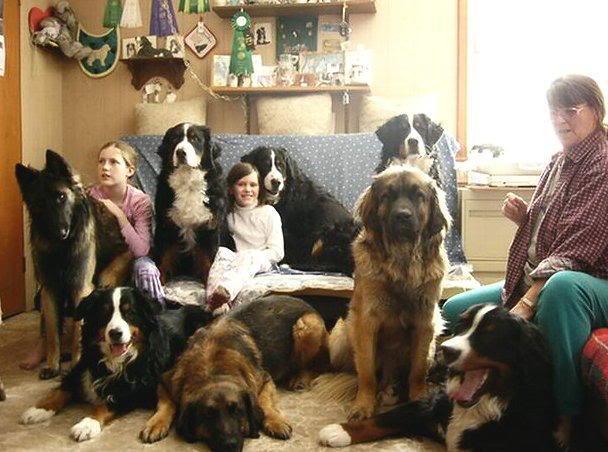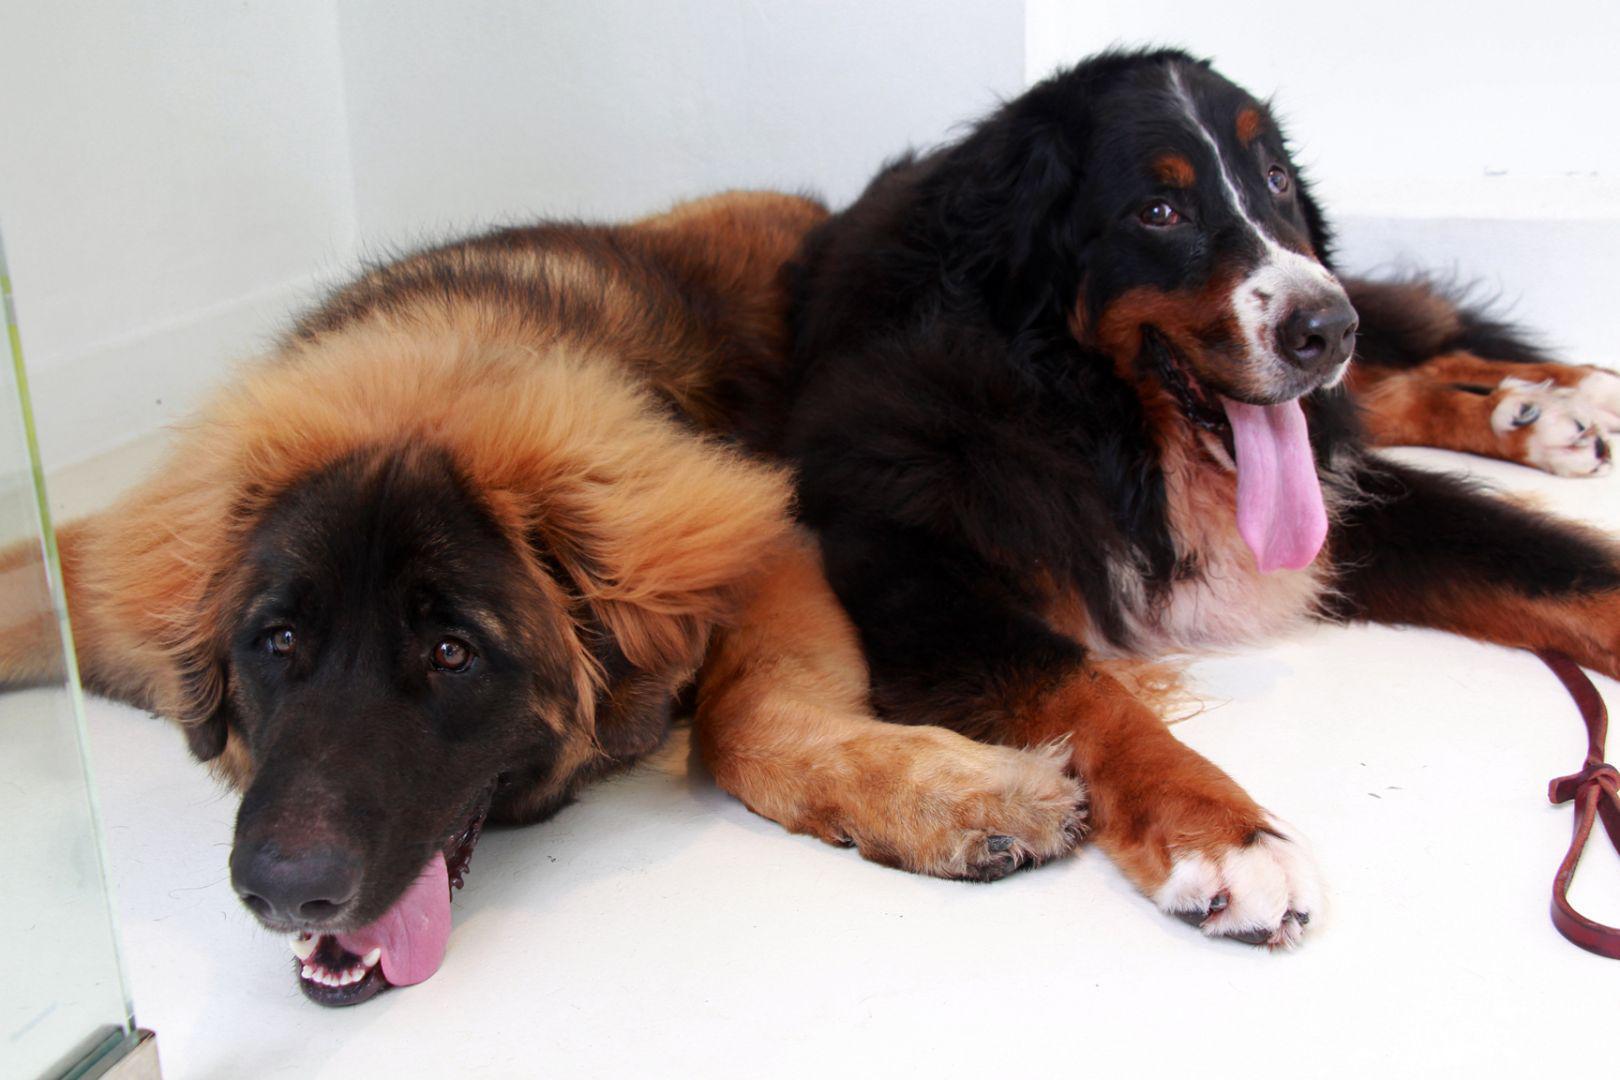The first image is the image on the left, the second image is the image on the right. Evaluate the accuracy of this statement regarding the images: "There are exactly two dogs lying in the image on the right.". Is it true? Answer yes or no. Yes. 